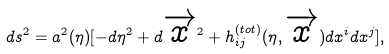Convert formula to latex. <formula><loc_0><loc_0><loc_500><loc_500>d s ^ { 2 } = a ^ { 2 } ( \eta ) [ - d \eta ^ { 2 } + d \overrightarrow { x } ^ { 2 } + h ^ { ( t o t ) } _ { i j } ( \eta , \overrightarrow { x } ) d x ^ { i } d x ^ { j } ] ,</formula> 